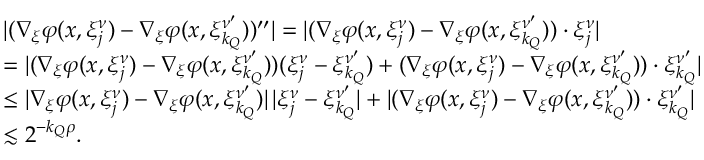Convert formula to latex. <formula><loc_0><loc_0><loc_500><loc_500>\begin{array} { r l } & { | ( \nabla _ { \xi } \varphi ( x , \xi _ { j } ^ { \nu } ) - \nabla _ { \xi } \varphi ( x , \xi _ { k _ { Q } } ^ { \nu ^ { \prime } } ) ) ^ { \prime \prime } | = | ( \nabla _ { \xi } \varphi ( x , \xi _ { j } ^ { \nu } ) - \nabla _ { \xi } \varphi ( x , \xi _ { k _ { Q } } ^ { \nu ^ { \prime } } ) ) \cdot \xi _ { j } ^ { \nu } | } \\ & { = | ( \nabla _ { \xi } \varphi ( x , \xi _ { j } ^ { \nu } ) - \nabla _ { \xi } \varphi ( x , \xi _ { k _ { Q } } ^ { \nu ^ { \prime } } ) ) ( \xi _ { j } ^ { \nu } - \xi _ { k _ { Q } } ^ { \nu ^ { \prime } } ) + ( \nabla _ { \xi } \varphi ( x , \xi _ { j } ^ { \nu } ) - \nabla _ { \xi } \varphi ( x , \xi _ { k _ { Q } } ^ { \nu ^ { \prime } } ) ) \cdot \xi _ { k _ { Q } } ^ { \nu ^ { \prime } } | } \\ & { \leq | \nabla _ { \xi } \varphi ( x , \xi _ { j } ^ { \nu } ) - \nabla _ { \xi } \varphi ( x , \xi _ { k _ { Q } } ^ { \nu ^ { \prime } } ) | \, | \xi _ { j } ^ { \nu } - \xi _ { k _ { Q } } ^ { \nu ^ { \prime } } | + | ( \nabla _ { \xi } \varphi ( x , \xi _ { j } ^ { \nu } ) - \nabla _ { \xi } \varphi ( x , \xi _ { k _ { Q } } ^ { \nu ^ { \prime } } ) ) \cdot \xi _ { k _ { Q } } ^ { \nu ^ { \prime } } | } \\ & { \lesssim 2 ^ { - { k _ { Q } } \rho } . } \end{array}</formula> 